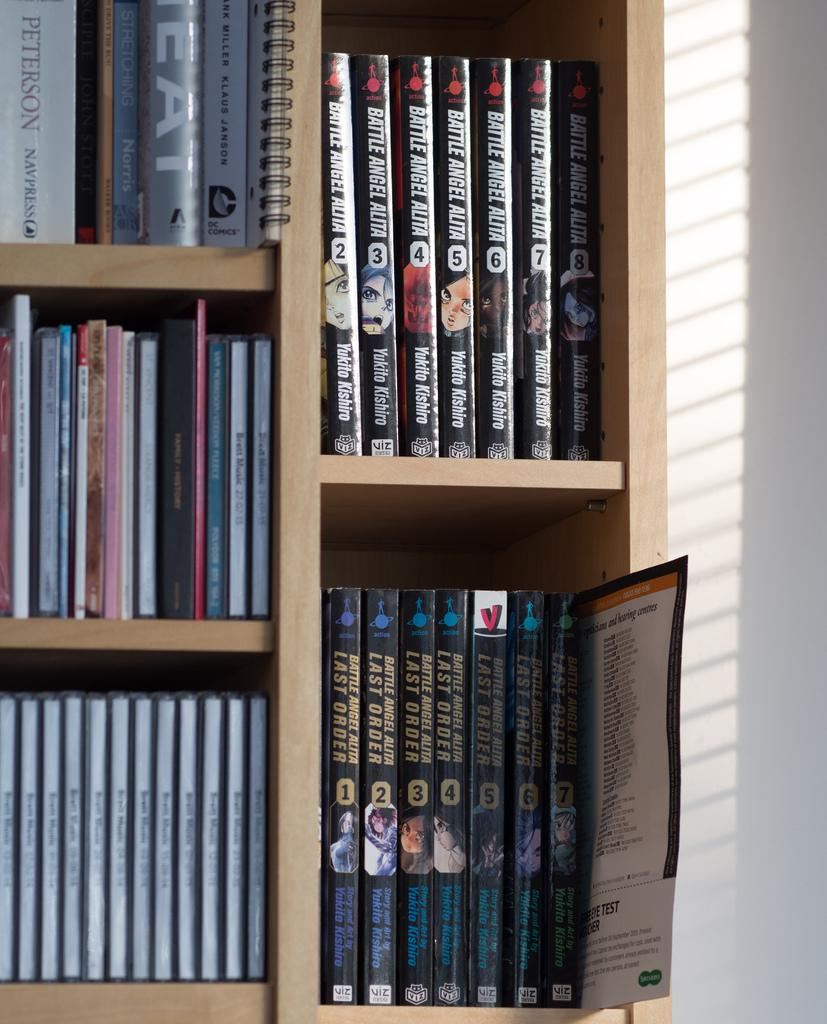<image>
Render a clear and concise summary of the photo. Bookshelf showing two sets of Battle Angle Alta. 